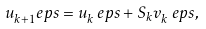<formula> <loc_0><loc_0><loc_500><loc_500>u _ { k + 1 } ^ { \ } e p s = u _ { k } ^ { \ } e p s + S _ { k } v _ { k } ^ { \ } e p s ,</formula> 